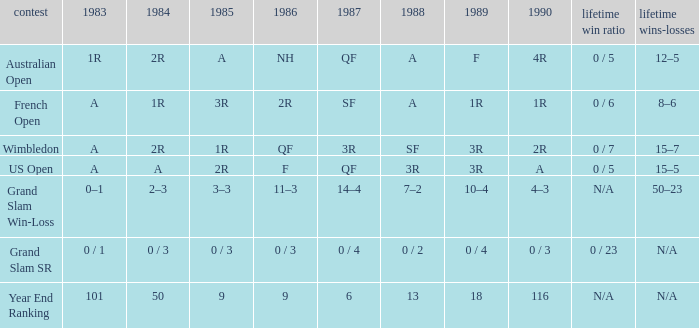What tournament has 0 / 5 as career SR and A as 1983? US Open. 